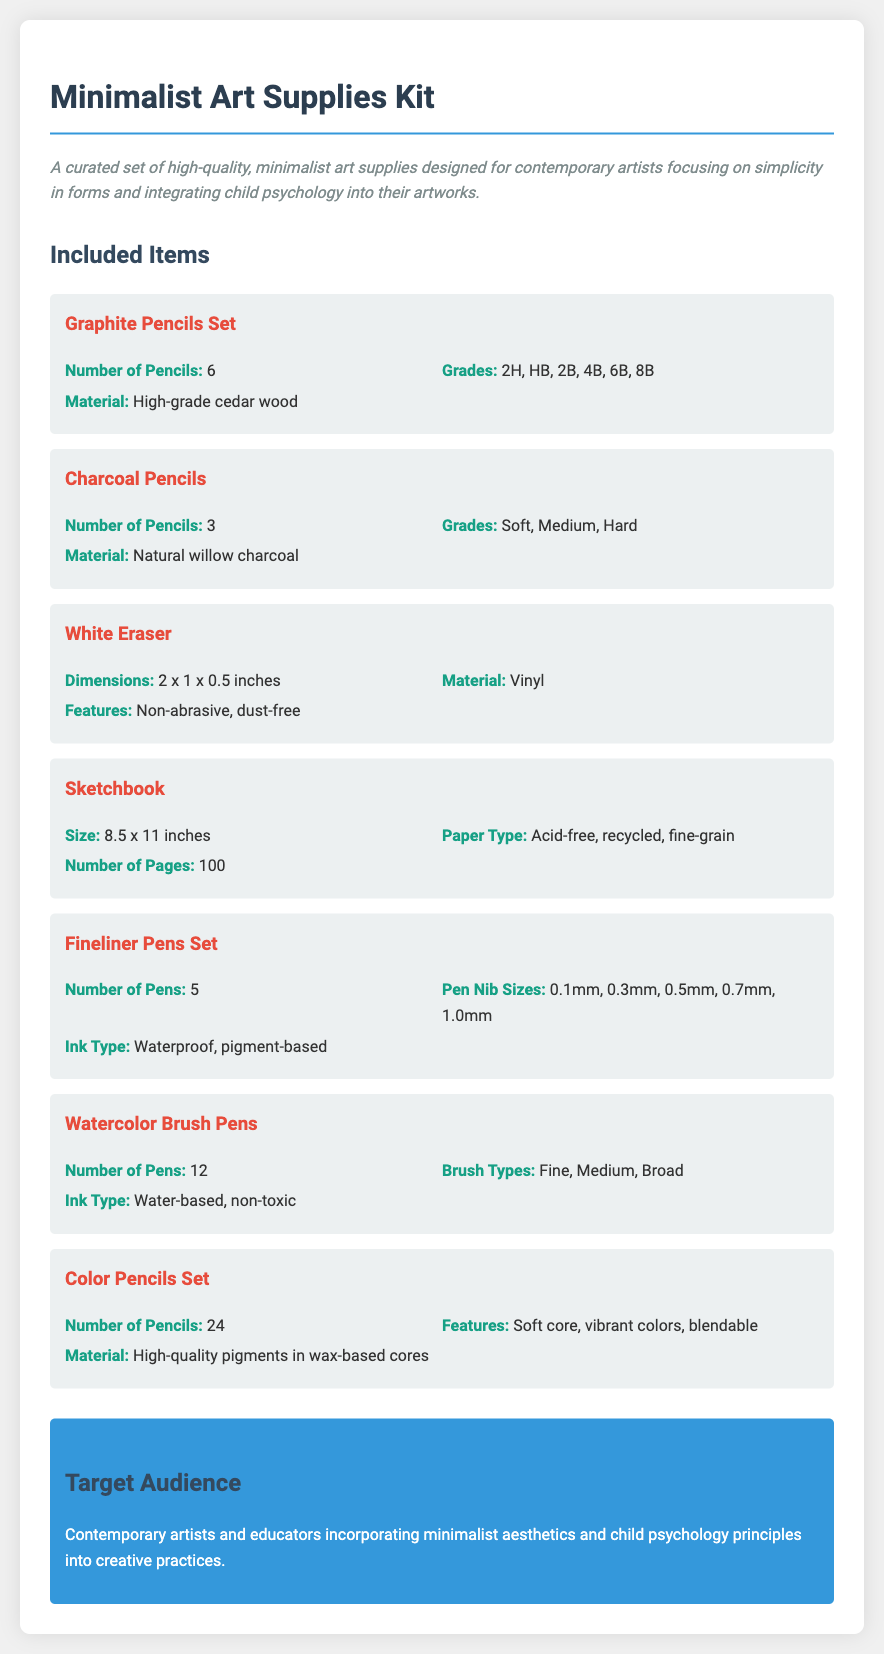What is the number of graphite pencils in the kit? The number of graphite pencils is specified as 6 in the document.
Answer: 6 What materials are the graphite pencils made of? The document states that the graphite pencils are made of high-grade cedar wood.
Answer: High-grade cedar wood How many pages does the sketchbook have? The number of pages in the sketchbook is mentioned as 100 in the document.
Answer: 100 What types of ink do the fineliner pens use? The ink type for the fineliner pens is described as waterproof, pigment-based in the document.
Answer: Waterproof, pigment-based What is the size of the white eraser? The dimensions of the white eraser are specified as 2 x 1 x 0.5 inches in the document.
Answer: 2 x 1 x 0.5 inches How many different grades are available for the charcoal pencils? The document mentions there are 3 grades for the charcoal pencils: Soft, Medium, Hard.
Answer: 3 Which item in the kit can be used for blending? The color pencils set features soft core and blendable properties, allowing for blending.
Answer: Color Pencils Set Who is the target audience for the art supplies kit? The document describes the target audience as contemporary artists and educators incorporating minimalist aesthetics and child psychology principles.
Answer: Contemporary artists and educators 